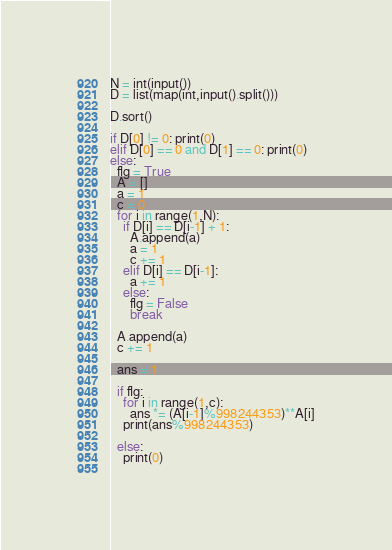<code> <loc_0><loc_0><loc_500><loc_500><_Python_>N = int(input())
D = list(map(int,input().split()))

D.sort()

if D[0] != 0: print(0)
elif D[0] == 0 and D[1] == 0: print(0)
else:
  flg = True
  A = []
  a = 1
  c = 0
  for i in range(1,N):
    if D[i] == D[i-1] + 1:
      A.append(a)
      a = 1
      c += 1
    elif D[i] == D[i-1]:
      a += 1
    else:
      flg = False
      break
  
  A.append(a)
  c += 1

  ans = 1

  if flg:
    for i in range(1,c):
      ans *= (A[i-1]%998244353)**A[i]
    print(ans%998244353)

  else:
    print(0)
  


</code> 